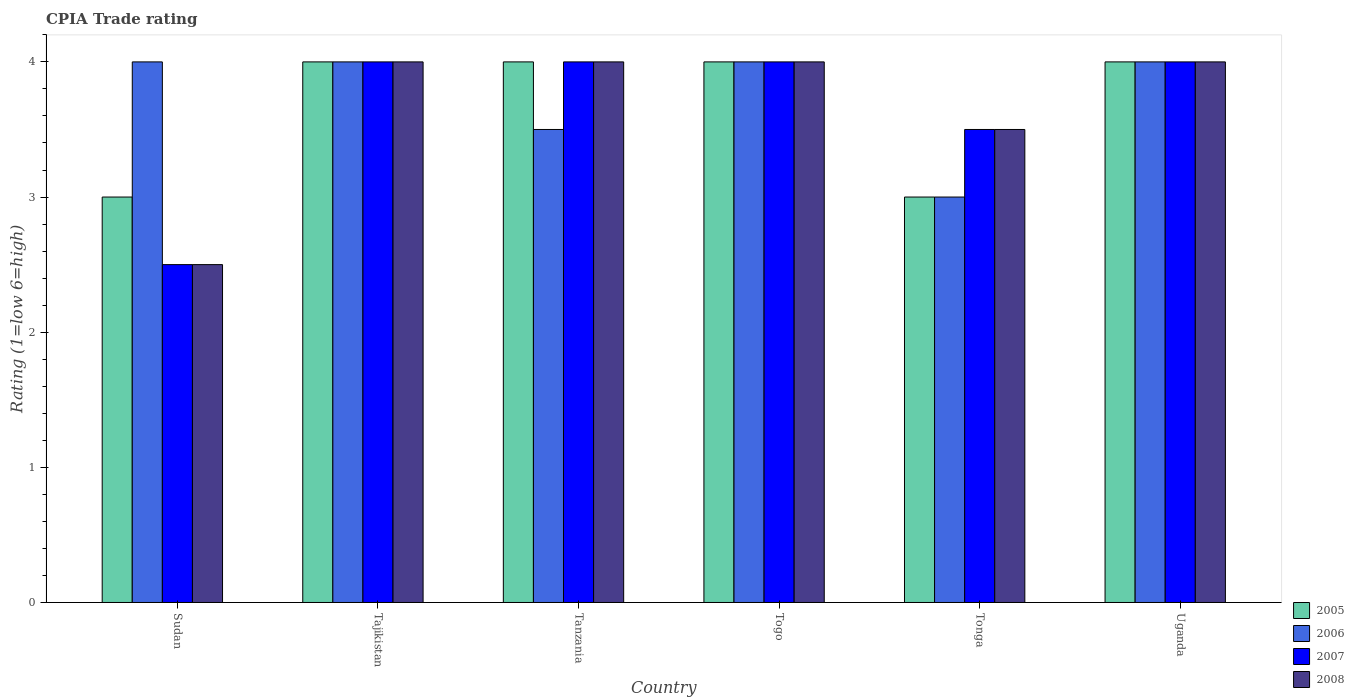How many different coloured bars are there?
Your answer should be very brief. 4. How many groups of bars are there?
Offer a terse response. 6. Are the number of bars on each tick of the X-axis equal?
Give a very brief answer. Yes. How many bars are there on the 4th tick from the right?
Offer a terse response. 4. What is the label of the 6th group of bars from the left?
Provide a short and direct response. Uganda. In how many cases, is the number of bars for a given country not equal to the number of legend labels?
Your response must be concise. 0. What is the CPIA rating in 2007 in Tanzania?
Keep it short and to the point. 4. Across all countries, what is the maximum CPIA rating in 2006?
Offer a terse response. 4. In which country was the CPIA rating in 2007 maximum?
Ensure brevity in your answer.  Tajikistan. In which country was the CPIA rating in 2005 minimum?
Provide a succinct answer. Sudan. What is the total CPIA rating in 2007 in the graph?
Your answer should be compact. 22. What is the difference between the CPIA rating in 2008 in Sudan and that in Uganda?
Make the answer very short. -1.5. What is the difference between the CPIA rating in 2005 in Tanzania and the CPIA rating in 2008 in Togo?
Your response must be concise. 0. What is the average CPIA rating in 2007 per country?
Make the answer very short. 3.67. Is the CPIA rating in 2006 in Sudan less than that in Togo?
Your answer should be very brief. No. In how many countries, is the CPIA rating in 2008 greater than the average CPIA rating in 2008 taken over all countries?
Keep it short and to the point. 4. Is it the case that in every country, the sum of the CPIA rating in 2007 and CPIA rating in 2008 is greater than the sum of CPIA rating in 2005 and CPIA rating in 2006?
Your response must be concise. No. What does the 3rd bar from the right in Tonga represents?
Offer a terse response. 2006. How many countries are there in the graph?
Your response must be concise. 6. What is the difference between two consecutive major ticks on the Y-axis?
Your answer should be very brief. 1. Does the graph contain any zero values?
Provide a succinct answer. No. Does the graph contain grids?
Provide a short and direct response. No. How are the legend labels stacked?
Offer a terse response. Vertical. What is the title of the graph?
Provide a succinct answer. CPIA Trade rating. What is the label or title of the X-axis?
Provide a short and direct response. Country. What is the label or title of the Y-axis?
Provide a short and direct response. Rating (1=low 6=high). What is the Rating (1=low 6=high) in 2005 in Sudan?
Provide a succinct answer. 3. What is the Rating (1=low 6=high) in 2006 in Sudan?
Provide a short and direct response. 4. What is the Rating (1=low 6=high) in 2007 in Sudan?
Provide a short and direct response. 2.5. What is the Rating (1=low 6=high) of 2007 in Tajikistan?
Your answer should be very brief. 4. What is the Rating (1=low 6=high) in 2006 in Tanzania?
Keep it short and to the point. 3.5. What is the Rating (1=low 6=high) in 2005 in Togo?
Your response must be concise. 4. What is the Rating (1=low 6=high) of 2007 in Togo?
Give a very brief answer. 4. What is the Rating (1=low 6=high) in 2008 in Togo?
Your response must be concise. 4. What is the Rating (1=low 6=high) of 2007 in Tonga?
Ensure brevity in your answer.  3.5. What is the Rating (1=low 6=high) in 2005 in Uganda?
Offer a terse response. 4. What is the Rating (1=low 6=high) in 2006 in Uganda?
Give a very brief answer. 4. What is the Rating (1=low 6=high) in 2007 in Uganda?
Keep it short and to the point. 4. Across all countries, what is the maximum Rating (1=low 6=high) of 2005?
Your answer should be compact. 4. Across all countries, what is the maximum Rating (1=low 6=high) of 2006?
Make the answer very short. 4. Across all countries, what is the maximum Rating (1=low 6=high) in 2008?
Offer a very short reply. 4. Across all countries, what is the minimum Rating (1=low 6=high) of 2006?
Ensure brevity in your answer.  3. Across all countries, what is the minimum Rating (1=low 6=high) in 2007?
Your answer should be compact. 2.5. Across all countries, what is the minimum Rating (1=low 6=high) of 2008?
Keep it short and to the point. 2.5. What is the total Rating (1=low 6=high) of 2008 in the graph?
Offer a very short reply. 22. What is the difference between the Rating (1=low 6=high) in 2005 in Sudan and that in Tajikistan?
Give a very brief answer. -1. What is the difference between the Rating (1=low 6=high) in 2006 in Sudan and that in Tajikistan?
Ensure brevity in your answer.  0. What is the difference between the Rating (1=low 6=high) of 2005 in Sudan and that in Tanzania?
Provide a short and direct response. -1. What is the difference between the Rating (1=low 6=high) of 2006 in Sudan and that in Tanzania?
Ensure brevity in your answer.  0.5. What is the difference between the Rating (1=low 6=high) in 2006 in Sudan and that in Togo?
Make the answer very short. 0. What is the difference between the Rating (1=low 6=high) of 2007 in Sudan and that in Togo?
Provide a succinct answer. -1.5. What is the difference between the Rating (1=low 6=high) of 2005 in Sudan and that in Tonga?
Make the answer very short. 0. What is the difference between the Rating (1=low 6=high) of 2007 in Sudan and that in Tonga?
Your answer should be very brief. -1. What is the difference between the Rating (1=low 6=high) in 2008 in Sudan and that in Tonga?
Offer a very short reply. -1. What is the difference between the Rating (1=low 6=high) in 2005 in Sudan and that in Uganda?
Your answer should be very brief. -1. What is the difference between the Rating (1=low 6=high) of 2006 in Sudan and that in Uganda?
Keep it short and to the point. 0. What is the difference between the Rating (1=low 6=high) of 2006 in Tajikistan and that in Tanzania?
Offer a terse response. 0.5. What is the difference between the Rating (1=low 6=high) in 2008 in Tajikistan and that in Tanzania?
Your response must be concise. 0. What is the difference between the Rating (1=low 6=high) in 2006 in Tajikistan and that in Togo?
Your answer should be very brief. 0. What is the difference between the Rating (1=low 6=high) in 2007 in Tajikistan and that in Togo?
Offer a terse response. 0. What is the difference between the Rating (1=low 6=high) of 2006 in Tajikistan and that in Tonga?
Keep it short and to the point. 1. What is the difference between the Rating (1=low 6=high) of 2008 in Tajikistan and that in Tonga?
Ensure brevity in your answer.  0.5. What is the difference between the Rating (1=low 6=high) of 2005 in Tajikistan and that in Uganda?
Your answer should be compact. 0. What is the difference between the Rating (1=low 6=high) of 2006 in Tanzania and that in Togo?
Your answer should be very brief. -0.5. What is the difference between the Rating (1=low 6=high) of 2005 in Tanzania and that in Tonga?
Provide a succinct answer. 1. What is the difference between the Rating (1=low 6=high) of 2006 in Tanzania and that in Tonga?
Provide a short and direct response. 0.5. What is the difference between the Rating (1=low 6=high) in 2007 in Tanzania and that in Tonga?
Provide a short and direct response. 0.5. What is the difference between the Rating (1=low 6=high) in 2005 in Tanzania and that in Uganda?
Keep it short and to the point. 0. What is the difference between the Rating (1=low 6=high) of 2007 in Tanzania and that in Uganda?
Your answer should be very brief. 0. What is the difference between the Rating (1=low 6=high) in 2006 in Togo and that in Tonga?
Make the answer very short. 1. What is the difference between the Rating (1=low 6=high) in 2007 in Togo and that in Tonga?
Give a very brief answer. 0.5. What is the difference between the Rating (1=low 6=high) in 2008 in Togo and that in Tonga?
Provide a succinct answer. 0.5. What is the difference between the Rating (1=low 6=high) of 2005 in Togo and that in Uganda?
Your response must be concise. 0. What is the difference between the Rating (1=low 6=high) in 2006 in Togo and that in Uganda?
Your answer should be compact. 0. What is the difference between the Rating (1=low 6=high) in 2007 in Togo and that in Uganda?
Your response must be concise. 0. What is the difference between the Rating (1=low 6=high) in 2005 in Tonga and that in Uganda?
Your answer should be compact. -1. What is the difference between the Rating (1=low 6=high) in 2007 in Tonga and that in Uganda?
Give a very brief answer. -0.5. What is the difference between the Rating (1=low 6=high) in 2005 in Sudan and the Rating (1=low 6=high) in 2007 in Tajikistan?
Your answer should be compact. -1. What is the difference between the Rating (1=low 6=high) of 2006 in Sudan and the Rating (1=low 6=high) of 2007 in Tajikistan?
Offer a terse response. 0. What is the difference between the Rating (1=low 6=high) of 2006 in Sudan and the Rating (1=low 6=high) of 2008 in Tajikistan?
Your answer should be very brief. 0. What is the difference between the Rating (1=low 6=high) in 2005 in Sudan and the Rating (1=low 6=high) in 2007 in Tanzania?
Offer a terse response. -1. What is the difference between the Rating (1=low 6=high) of 2006 in Sudan and the Rating (1=low 6=high) of 2007 in Tanzania?
Provide a short and direct response. 0. What is the difference between the Rating (1=low 6=high) of 2006 in Sudan and the Rating (1=low 6=high) of 2008 in Tanzania?
Your answer should be very brief. 0. What is the difference between the Rating (1=low 6=high) of 2007 in Sudan and the Rating (1=low 6=high) of 2008 in Tanzania?
Make the answer very short. -1.5. What is the difference between the Rating (1=low 6=high) in 2005 in Sudan and the Rating (1=low 6=high) in 2006 in Togo?
Give a very brief answer. -1. What is the difference between the Rating (1=low 6=high) of 2005 in Sudan and the Rating (1=low 6=high) of 2007 in Togo?
Offer a very short reply. -1. What is the difference between the Rating (1=low 6=high) of 2005 in Sudan and the Rating (1=low 6=high) of 2007 in Tonga?
Keep it short and to the point. -0.5. What is the difference between the Rating (1=low 6=high) in 2005 in Sudan and the Rating (1=low 6=high) in 2007 in Uganda?
Keep it short and to the point. -1. What is the difference between the Rating (1=low 6=high) of 2006 in Sudan and the Rating (1=low 6=high) of 2008 in Uganda?
Offer a terse response. 0. What is the difference between the Rating (1=low 6=high) in 2007 in Sudan and the Rating (1=low 6=high) in 2008 in Uganda?
Your response must be concise. -1.5. What is the difference between the Rating (1=low 6=high) of 2005 in Tajikistan and the Rating (1=low 6=high) of 2006 in Tanzania?
Your answer should be compact. 0.5. What is the difference between the Rating (1=low 6=high) in 2006 in Tajikistan and the Rating (1=low 6=high) in 2007 in Tanzania?
Make the answer very short. 0. What is the difference between the Rating (1=low 6=high) of 2007 in Tajikistan and the Rating (1=low 6=high) of 2008 in Tanzania?
Provide a succinct answer. 0. What is the difference between the Rating (1=low 6=high) of 2005 in Tajikistan and the Rating (1=low 6=high) of 2006 in Togo?
Ensure brevity in your answer.  0. What is the difference between the Rating (1=low 6=high) of 2007 in Tajikistan and the Rating (1=low 6=high) of 2008 in Togo?
Keep it short and to the point. 0. What is the difference between the Rating (1=low 6=high) of 2005 in Tajikistan and the Rating (1=low 6=high) of 2007 in Tonga?
Provide a short and direct response. 0.5. What is the difference between the Rating (1=low 6=high) of 2005 in Tajikistan and the Rating (1=low 6=high) of 2008 in Tonga?
Ensure brevity in your answer.  0.5. What is the difference between the Rating (1=low 6=high) of 2007 in Tajikistan and the Rating (1=low 6=high) of 2008 in Tonga?
Provide a succinct answer. 0.5. What is the difference between the Rating (1=low 6=high) in 2005 in Tajikistan and the Rating (1=low 6=high) in 2006 in Uganda?
Ensure brevity in your answer.  0. What is the difference between the Rating (1=low 6=high) of 2005 in Tajikistan and the Rating (1=low 6=high) of 2007 in Uganda?
Your answer should be compact. 0. What is the difference between the Rating (1=low 6=high) in 2006 in Tajikistan and the Rating (1=low 6=high) in 2008 in Uganda?
Give a very brief answer. 0. What is the difference between the Rating (1=low 6=high) in 2007 in Tajikistan and the Rating (1=low 6=high) in 2008 in Uganda?
Your response must be concise. 0. What is the difference between the Rating (1=low 6=high) in 2005 in Tanzania and the Rating (1=low 6=high) in 2007 in Togo?
Keep it short and to the point. 0. What is the difference between the Rating (1=low 6=high) in 2005 in Tanzania and the Rating (1=low 6=high) in 2008 in Togo?
Your response must be concise. 0. What is the difference between the Rating (1=low 6=high) of 2006 in Tanzania and the Rating (1=low 6=high) of 2007 in Togo?
Provide a succinct answer. -0.5. What is the difference between the Rating (1=low 6=high) in 2006 in Tanzania and the Rating (1=low 6=high) in 2008 in Togo?
Ensure brevity in your answer.  -0.5. What is the difference between the Rating (1=low 6=high) in 2005 in Tanzania and the Rating (1=low 6=high) in 2007 in Tonga?
Your answer should be compact. 0.5. What is the difference between the Rating (1=low 6=high) in 2005 in Tanzania and the Rating (1=low 6=high) in 2008 in Tonga?
Provide a succinct answer. 0.5. What is the difference between the Rating (1=low 6=high) in 2006 in Tanzania and the Rating (1=low 6=high) in 2007 in Tonga?
Your answer should be compact. 0. What is the difference between the Rating (1=low 6=high) of 2006 in Tanzania and the Rating (1=low 6=high) of 2008 in Tonga?
Ensure brevity in your answer.  0. What is the difference between the Rating (1=low 6=high) in 2007 in Tanzania and the Rating (1=low 6=high) in 2008 in Tonga?
Ensure brevity in your answer.  0.5. What is the difference between the Rating (1=low 6=high) of 2005 in Tanzania and the Rating (1=low 6=high) of 2006 in Uganda?
Offer a very short reply. 0. What is the difference between the Rating (1=low 6=high) in 2007 in Tanzania and the Rating (1=low 6=high) in 2008 in Uganda?
Provide a short and direct response. 0. What is the difference between the Rating (1=low 6=high) of 2005 in Togo and the Rating (1=low 6=high) of 2007 in Tonga?
Give a very brief answer. 0.5. What is the difference between the Rating (1=low 6=high) of 2006 in Togo and the Rating (1=low 6=high) of 2007 in Tonga?
Provide a short and direct response. 0.5. What is the difference between the Rating (1=low 6=high) in 2007 in Togo and the Rating (1=low 6=high) in 2008 in Tonga?
Your answer should be very brief. 0.5. What is the difference between the Rating (1=low 6=high) of 2005 in Togo and the Rating (1=low 6=high) of 2006 in Uganda?
Ensure brevity in your answer.  0. What is the difference between the Rating (1=low 6=high) in 2006 in Togo and the Rating (1=low 6=high) in 2007 in Uganda?
Ensure brevity in your answer.  0. What is the difference between the Rating (1=low 6=high) in 2006 in Tonga and the Rating (1=low 6=high) in 2007 in Uganda?
Your answer should be very brief. -1. What is the difference between the Rating (1=low 6=high) of 2006 in Tonga and the Rating (1=low 6=high) of 2008 in Uganda?
Give a very brief answer. -1. What is the difference between the Rating (1=low 6=high) of 2007 in Tonga and the Rating (1=low 6=high) of 2008 in Uganda?
Keep it short and to the point. -0.5. What is the average Rating (1=low 6=high) in 2005 per country?
Offer a terse response. 3.67. What is the average Rating (1=low 6=high) of 2006 per country?
Ensure brevity in your answer.  3.75. What is the average Rating (1=low 6=high) in 2007 per country?
Offer a very short reply. 3.67. What is the average Rating (1=low 6=high) of 2008 per country?
Offer a terse response. 3.67. What is the difference between the Rating (1=low 6=high) in 2005 and Rating (1=low 6=high) in 2006 in Sudan?
Your response must be concise. -1. What is the difference between the Rating (1=low 6=high) of 2005 and Rating (1=low 6=high) of 2007 in Sudan?
Offer a very short reply. 0.5. What is the difference between the Rating (1=low 6=high) of 2005 and Rating (1=low 6=high) of 2008 in Sudan?
Keep it short and to the point. 0.5. What is the difference between the Rating (1=low 6=high) in 2006 and Rating (1=low 6=high) in 2007 in Sudan?
Your answer should be compact. 1.5. What is the difference between the Rating (1=low 6=high) of 2006 and Rating (1=low 6=high) of 2008 in Sudan?
Ensure brevity in your answer.  1.5. What is the difference between the Rating (1=low 6=high) in 2006 and Rating (1=low 6=high) in 2008 in Tajikistan?
Make the answer very short. 0. What is the difference between the Rating (1=low 6=high) in 2007 and Rating (1=low 6=high) in 2008 in Tajikistan?
Give a very brief answer. 0. What is the difference between the Rating (1=low 6=high) of 2005 and Rating (1=low 6=high) of 2006 in Tanzania?
Offer a terse response. 0.5. What is the difference between the Rating (1=low 6=high) of 2005 and Rating (1=low 6=high) of 2008 in Tanzania?
Offer a terse response. 0. What is the difference between the Rating (1=low 6=high) in 2006 and Rating (1=low 6=high) in 2008 in Tanzania?
Make the answer very short. -0.5. What is the difference between the Rating (1=low 6=high) of 2007 and Rating (1=low 6=high) of 2008 in Tanzania?
Provide a short and direct response. 0. What is the difference between the Rating (1=low 6=high) in 2005 and Rating (1=low 6=high) in 2007 in Togo?
Your answer should be very brief. 0. What is the difference between the Rating (1=low 6=high) of 2006 and Rating (1=low 6=high) of 2007 in Togo?
Provide a short and direct response. 0. What is the difference between the Rating (1=low 6=high) of 2006 and Rating (1=low 6=high) of 2008 in Togo?
Give a very brief answer. 0. What is the difference between the Rating (1=low 6=high) in 2007 and Rating (1=low 6=high) in 2008 in Togo?
Provide a short and direct response. 0. What is the difference between the Rating (1=low 6=high) of 2005 and Rating (1=low 6=high) of 2006 in Tonga?
Give a very brief answer. 0. What is the difference between the Rating (1=low 6=high) in 2005 and Rating (1=low 6=high) in 2007 in Tonga?
Your answer should be compact. -0.5. What is the difference between the Rating (1=low 6=high) of 2006 and Rating (1=low 6=high) of 2007 in Tonga?
Provide a short and direct response. -0.5. What is the difference between the Rating (1=low 6=high) in 2007 and Rating (1=low 6=high) in 2008 in Tonga?
Your answer should be compact. 0. What is the difference between the Rating (1=low 6=high) in 2006 and Rating (1=low 6=high) in 2007 in Uganda?
Keep it short and to the point. 0. What is the difference between the Rating (1=low 6=high) in 2006 and Rating (1=low 6=high) in 2008 in Uganda?
Your answer should be very brief. 0. What is the difference between the Rating (1=low 6=high) in 2007 and Rating (1=low 6=high) in 2008 in Uganda?
Offer a very short reply. 0. What is the ratio of the Rating (1=low 6=high) of 2006 in Sudan to that in Tajikistan?
Offer a terse response. 1. What is the ratio of the Rating (1=low 6=high) of 2007 in Sudan to that in Tajikistan?
Ensure brevity in your answer.  0.62. What is the ratio of the Rating (1=low 6=high) of 2008 in Sudan to that in Tajikistan?
Your response must be concise. 0.62. What is the ratio of the Rating (1=low 6=high) of 2006 in Sudan to that in Tanzania?
Provide a short and direct response. 1.14. What is the ratio of the Rating (1=low 6=high) of 2007 in Sudan to that in Tanzania?
Offer a very short reply. 0.62. What is the ratio of the Rating (1=low 6=high) in 2008 in Sudan to that in Tanzania?
Offer a terse response. 0.62. What is the ratio of the Rating (1=low 6=high) in 2005 in Sudan to that in Togo?
Your answer should be compact. 0.75. What is the ratio of the Rating (1=low 6=high) in 2006 in Sudan to that in Togo?
Your response must be concise. 1. What is the ratio of the Rating (1=low 6=high) of 2007 in Sudan to that in Togo?
Provide a short and direct response. 0.62. What is the ratio of the Rating (1=low 6=high) in 2008 in Sudan to that in Togo?
Offer a terse response. 0.62. What is the ratio of the Rating (1=low 6=high) in 2008 in Sudan to that in Tonga?
Provide a succinct answer. 0.71. What is the ratio of the Rating (1=low 6=high) in 2005 in Sudan to that in Uganda?
Offer a very short reply. 0.75. What is the ratio of the Rating (1=low 6=high) in 2008 in Sudan to that in Uganda?
Offer a terse response. 0.62. What is the ratio of the Rating (1=low 6=high) in 2008 in Tajikistan to that in Tanzania?
Your response must be concise. 1. What is the ratio of the Rating (1=low 6=high) of 2006 in Tajikistan to that in Togo?
Your response must be concise. 1. What is the ratio of the Rating (1=low 6=high) of 2008 in Tajikistan to that in Togo?
Offer a terse response. 1. What is the ratio of the Rating (1=low 6=high) in 2005 in Tajikistan to that in Tonga?
Your answer should be very brief. 1.33. What is the ratio of the Rating (1=low 6=high) of 2006 in Tajikistan to that in Tonga?
Keep it short and to the point. 1.33. What is the ratio of the Rating (1=low 6=high) in 2008 in Tajikistan to that in Tonga?
Offer a terse response. 1.14. What is the ratio of the Rating (1=low 6=high) of 2005 in Tajikistan to that in Uganda?
Make the answer very short. 1. What is the ratio of the Rating (1=low 6=high) in 2008 in Tajikistan to that in Uganda?
Your answer should be very brief. 1. What is the ratio of the Rating (1=low 6=high) in 2008 in Tanzania to that in Togo?
Your answer should be compact. 1. What is the ratio of the Rating (1=low 6=high) of 2005 in Tanzania to that in Tonga?
Provide a short and direct response. 1.33. What is the ratio of the Rating (1=low 6=high) of 2007 in Tanzania to that in Tonga?
Offer a terse response. 1.14. What is the ratio of the Rating (1=low 6=high) of 2008 in Tanzania to that in Tonga?
Provide a short and direct response. 1.14. What is the ratio of the Rating (1=low 6=high) of 2005 in Tanzania to that in Uganda?
Your response must be concise. 1. What is the ratio of the Rating (1=low 6=high) of 2008 in Tanzania to that in Uganda?
Your answer should be compact. 1. What is the ratio of the Rating (1=low 6=high) of 2005 in Togo to that in Tonga?
Keep it short and to the point. 1.33. What is the ratio of the Rating (1=low 6=high) of 2007 in Togo to that in Tonga?
Offer a terse response. 1.14. What is the ratio of the Rating (1=low 6=high) in 2008 in Togo to that in Tonga?
Your answer should be very brief. 1.14. What is the ratio of the Rating (1=low 6=high) of 2005 in Togo to that in Uganda?
Offer a terse response. 1. What is the ratio of the Rating (1=low 6=high) of 2008 in Tonga to that in Uganda?
Provide a succinct answer. 0.88. What is the difference between the highest and the second highest Rating (1=low 6=high) in 2006?
Offer a terse response. 0. What is the difference between the highest and the second highest Rating (1=low 6=high) of 2007?
Make the answer very short. 0. What is the difference between the highest and the lowest Rating (1=low 6=high) of 2005?
Provide a succinct answer. 1. 